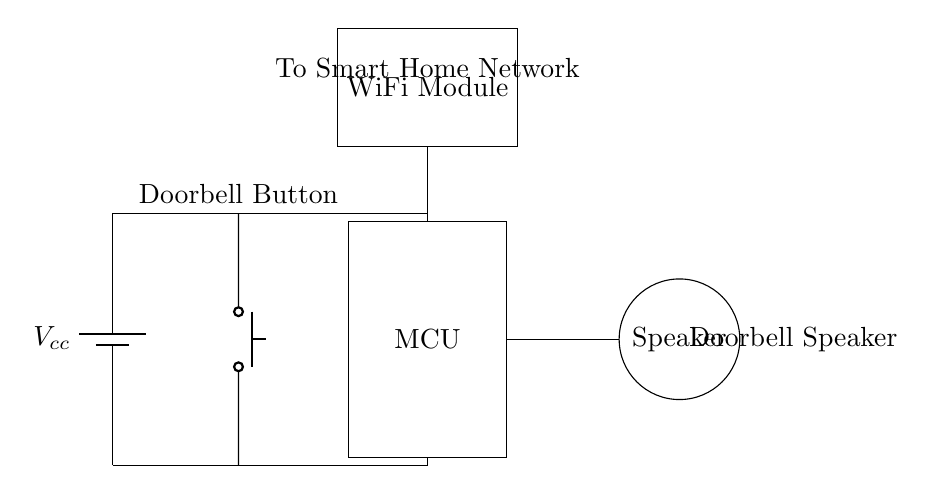What types of components are included in this circuit? The circuit includes a battery, push button, microcontroller, speaker, and WiFi module. These are identified by examining the diagram and noting the various labeled elements.
Answer: Battery, push button, microcontroller, speaker, WiFi module What is the purpose of the push button in this circuit? The push button is used to activate the doorbell function by sending a signal to the microcontroller when pressed. This purpose is inferred from its placement in the circuit and common usage in doorbell designs.
Answer: Activate doorbell function What component connects the MCU to the speaker? The microcontroller (MCU) is connected to the speaker through a direct line indicating the signal flow from the MCU to the speaker, which is typically how sound is generated in such circuits.
Answer: Wired connection How does the doorbell button signal reach the WiFi module? The signal from the doorbell button travels through the microcontroller, which processes the signal before sending it to the WiFi module, facilitating smart home integration. This is determined by the connections shown in the circuit.
Answer: Through the microcontroller What is the voltage source used in this circuit? The voltage source used in this circuit is denoted by the symbol of a battery labeled \(V_{cc}\), which commonly indicates the power supply voltage in electronic circuits.
Answer: Vcc What is the function of the WiFi module in this circuit? The WiFi module connects the microcontroller to the smart home network, allowing remote access and control of the doorbell. This function is inferred by the label and typical use of such modules in smart devices.
Answer: Connect to smart home network 